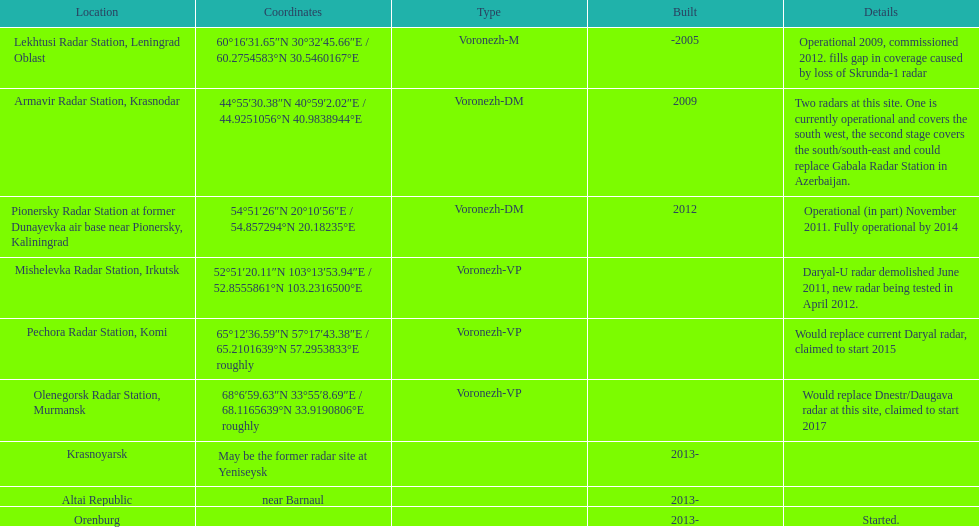What is the only location with a coordination of 60°16&#8242;31.65&#8243;n 30°32&#8242;45.66&#8243;e / 60.2754583°n 30.5460167°e? Lekhtusi Radar Station, Leningrad Oblast. 